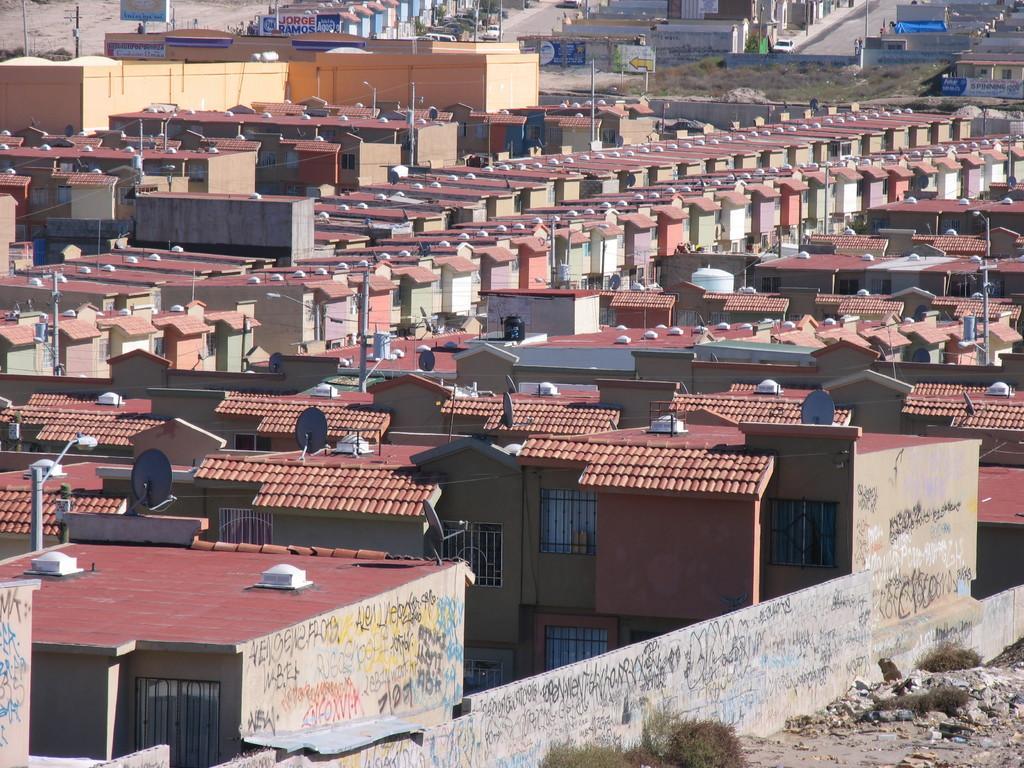Please provide a concise description of this image. In this image we can see many buildings with windows. On the walls of the building there is text. And there is a compound wall. Also we can see dish antennas and light poles. 